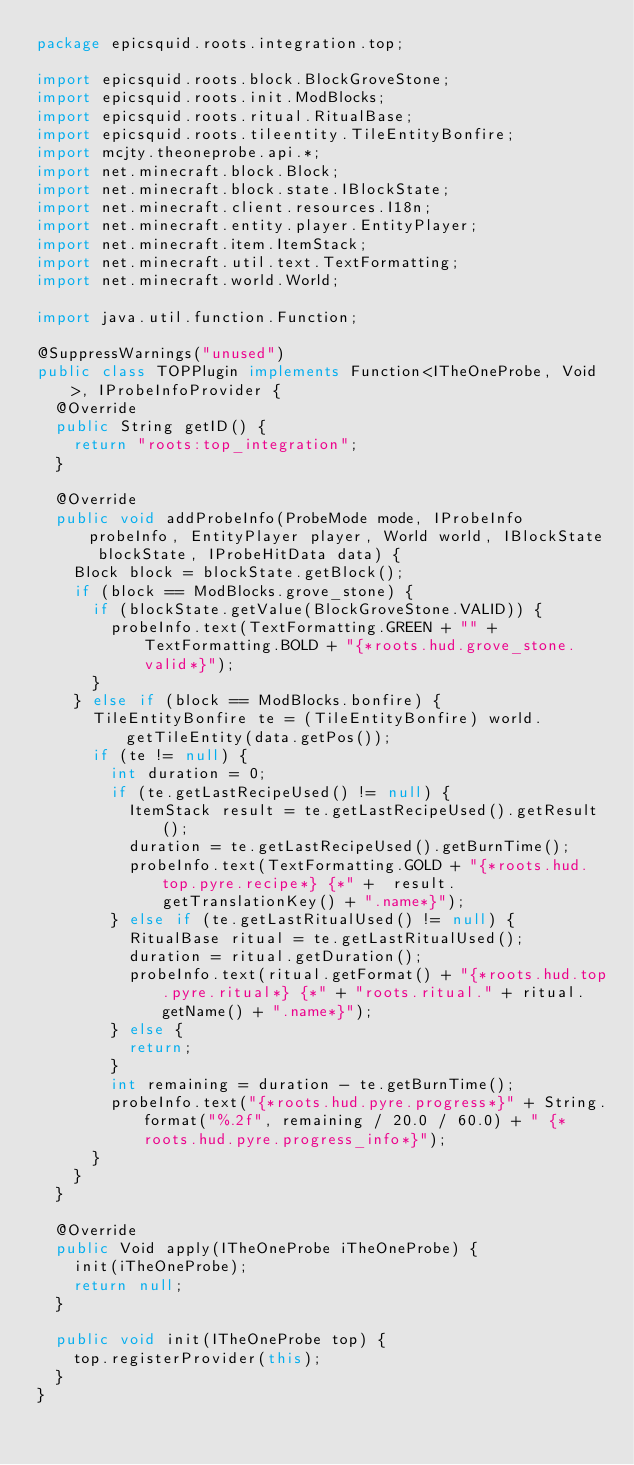Convert code to text. <code><loc_0><loc_0><loc_500><loc_500><_Java_>package epicsquid.roots.integration.top;

import epicsquid.roots.block.BlockGroveStone;
import epicsquid.roots.init.ModBlocks;
import epicsquid.roots.ritual.RitualBase;
import epicsquid.roots.tileentity.TileEntityBonfire;
import mcjty.theoneprobe.api.*;
import net.minecraft.block.Block;
import net.minecraft.block.state.IBlockState;
import net.minecraft.client.resources.I18n;
import net.minecraft.entity.player.EntityPlayer;
import net.minecraft.item.ItemStack;
import net.minecraft.util.text.TextFormatting;
import net.minecraft.world.World;

import java.util.function.Function;

@SuppressWarnings("unused")
public class TOPPlugin implements Function<ITheOneProbe, Void>, IProbeInfoProvider {
  @Override
  public String getID() {
    return "roots:top_integration";
  }

  @Override
  public void addProbeInfo(ProbeMode mode, IProbeInfo probeInfo, EntityPlayer player, World world, IBlockState blockState, IProbeHitData data) {
    Block block = blockState.getBlock();
    if (block == ModBlocks.grove_stone) {
      if (blockState.getValue(BlockGroveStone.VALID)) {
        probeInfo.text(TextFormatting.GREEN + "" + TextFormatting.BOLD + "{*roots.hud.grove_stone.valid*}");
      }
    } else if (block == ModBlocks.bonfire) {
      TileEntityBonfire te = (TileEntityBonfire) world.getTileEntity(data.getPos());
      if (te != null) {
        int duration = 0;
        if (te.getLastRecipeUsed() != null) {
          ItemStack result = te.getLastRecipeUsed().getResult();
          duration = te.getLastRecipeUsed().getBurnTime();
          probeInfo.text(TextFormatting.GOLD + "{*roots.hud.top.pyre.recipe*} {*" +  result.getTranslationKey() + ".name*}");
        } else if (te.getLastRitualUsed() != null) {
          RitualBase ritual = te.getLastRitualUsed();
          duration = ritual.getDuration();
          probeInfo.text(ritual.getFormat() + "{*roots.hud.top.pyre.ritual*} {*" + "roots.ritual." + ritual.getName() + ".name*}");
        } else {
          return;
        }
        int remaining = duration - te.getBurnTime();
        probeInfo.text("{*roots.hud.pyre.progress*}" + String.format("%.2f", remaining / 20.0 / 60.0) + " {*roots.hud.pyre.progress_info*}");
      }
    }
  }

  @Override
  public Void apply(ITheOneProbe iTheOneProbe) {
    init(iTheOneProbe);
    return null;
  }

  public void init(ITheOneProbe top) {
    top.registerProvider(this);
  }
}
</code> 